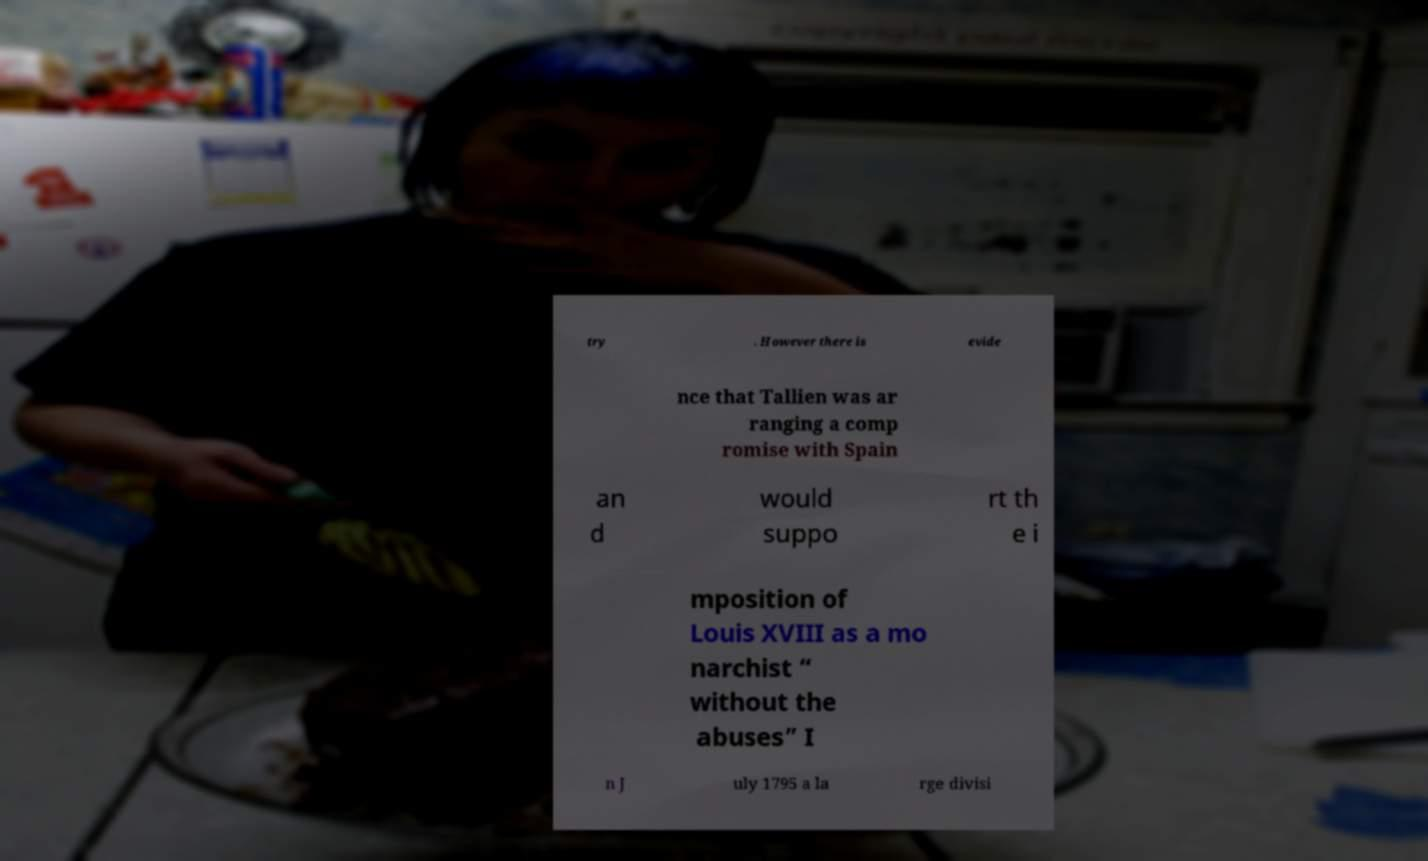Please read and relay the text visible in this image. What does it say? try . However there is evide nce that Tallien was ar ranging a comp romise with Spain an d would suppo rt th e i mposition of Louis XVIII as a mo narchist “ without the abuses” I n J uly 1795 a la rge divisi 